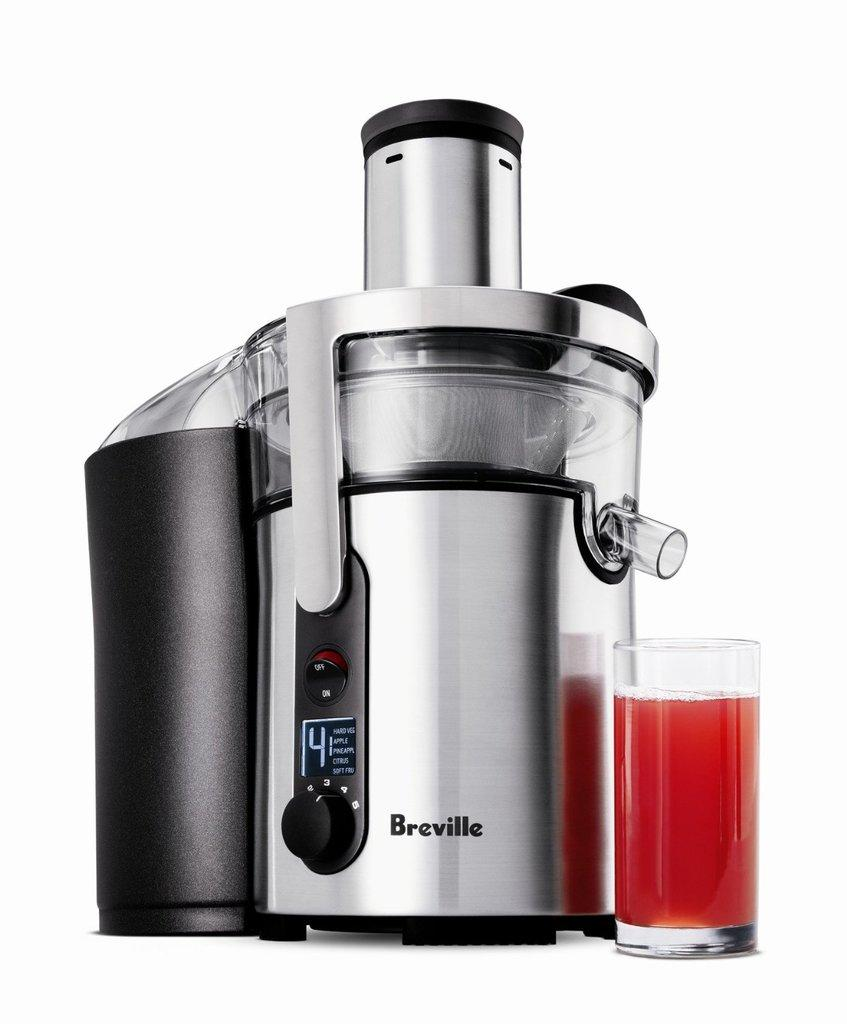<image>
Describe the image concisely. A Breville brand juicer has a clear glass of red liquid next to it. 